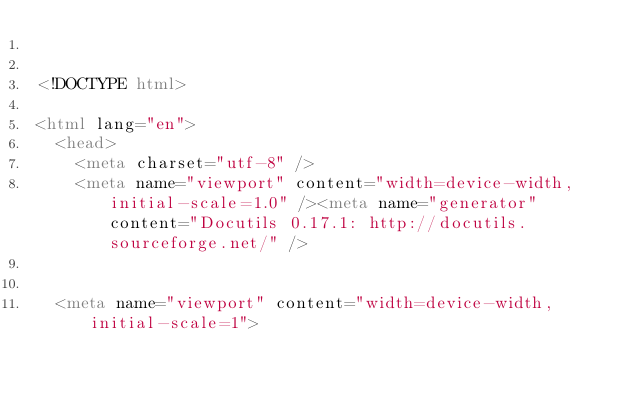Convert code to text. <code><loc_0><loc_0><loc_500><loc_500><_HTML_>

<!DOCTYPE html>

<html lang="en">
  <head>
    <meta charset="utf-8" />
    <meta name="viewport" content="width=device-width, initial-scale=1.0" /><meta name="generator" content="Docutils 0.17.1: http://docutils.sourceforge.net/" />

  
  <meta name="viewport" content="width=device-width,initial-scale=1"></code> 